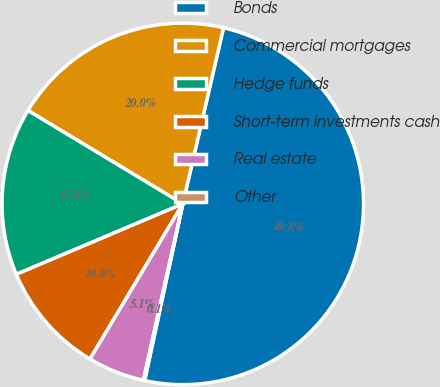Convert chart to OTSL. <chart><loc_0><loc_0><loc_500><loc_500><pie_chart><fcel>Bonds<fcel>Commercial mortgages<fcel>Hedge funds<fcel>Short-term investments cash<fcel>Real estate<fcel>Other<nl><fcel>49.77%<fcel>19.98%<fcel>15.01%<fcel>10.05%<fcel>5.08%<fcel>0.12%<nl></chart> 